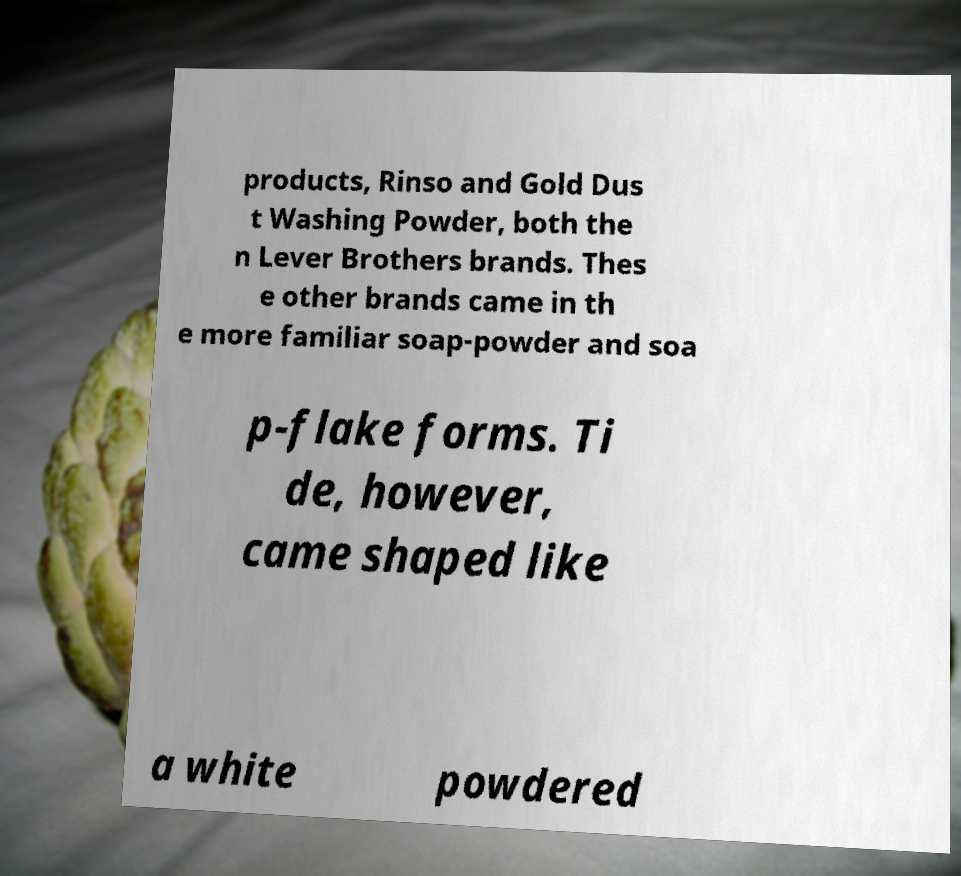Please identify and transcribe the text found in this image. products, Rinso and Gold Dus t Washing Powder, both the n Lever Brothers brands. Thes e other brands came in th e more familiar soap-powder and soa p-flake forms. Ti de, however, came shaped like a white powdered 